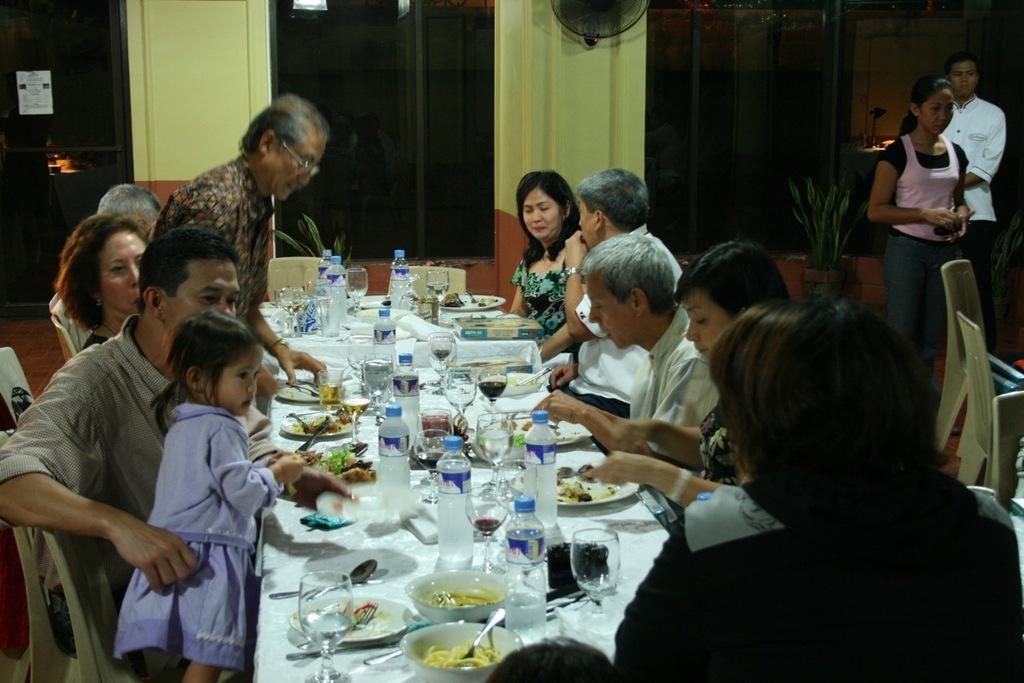How would you summarize this image in a sentence or two? Few persons are sitting on the chair and few persons are standing. We can see bottles,glasses,plates,spoons,food and things on the table. On the background we can see wall,window,plant,fan. 